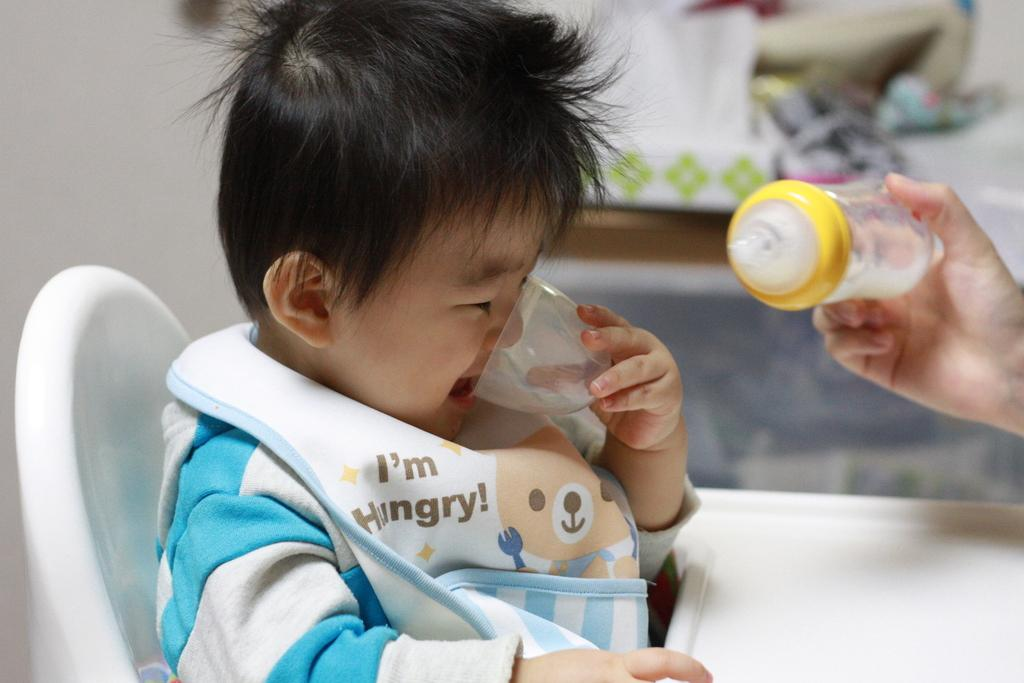Provide a one-sentence caption for the provided image. A toddler is drinking from a cup while a bottle is offered to him. 